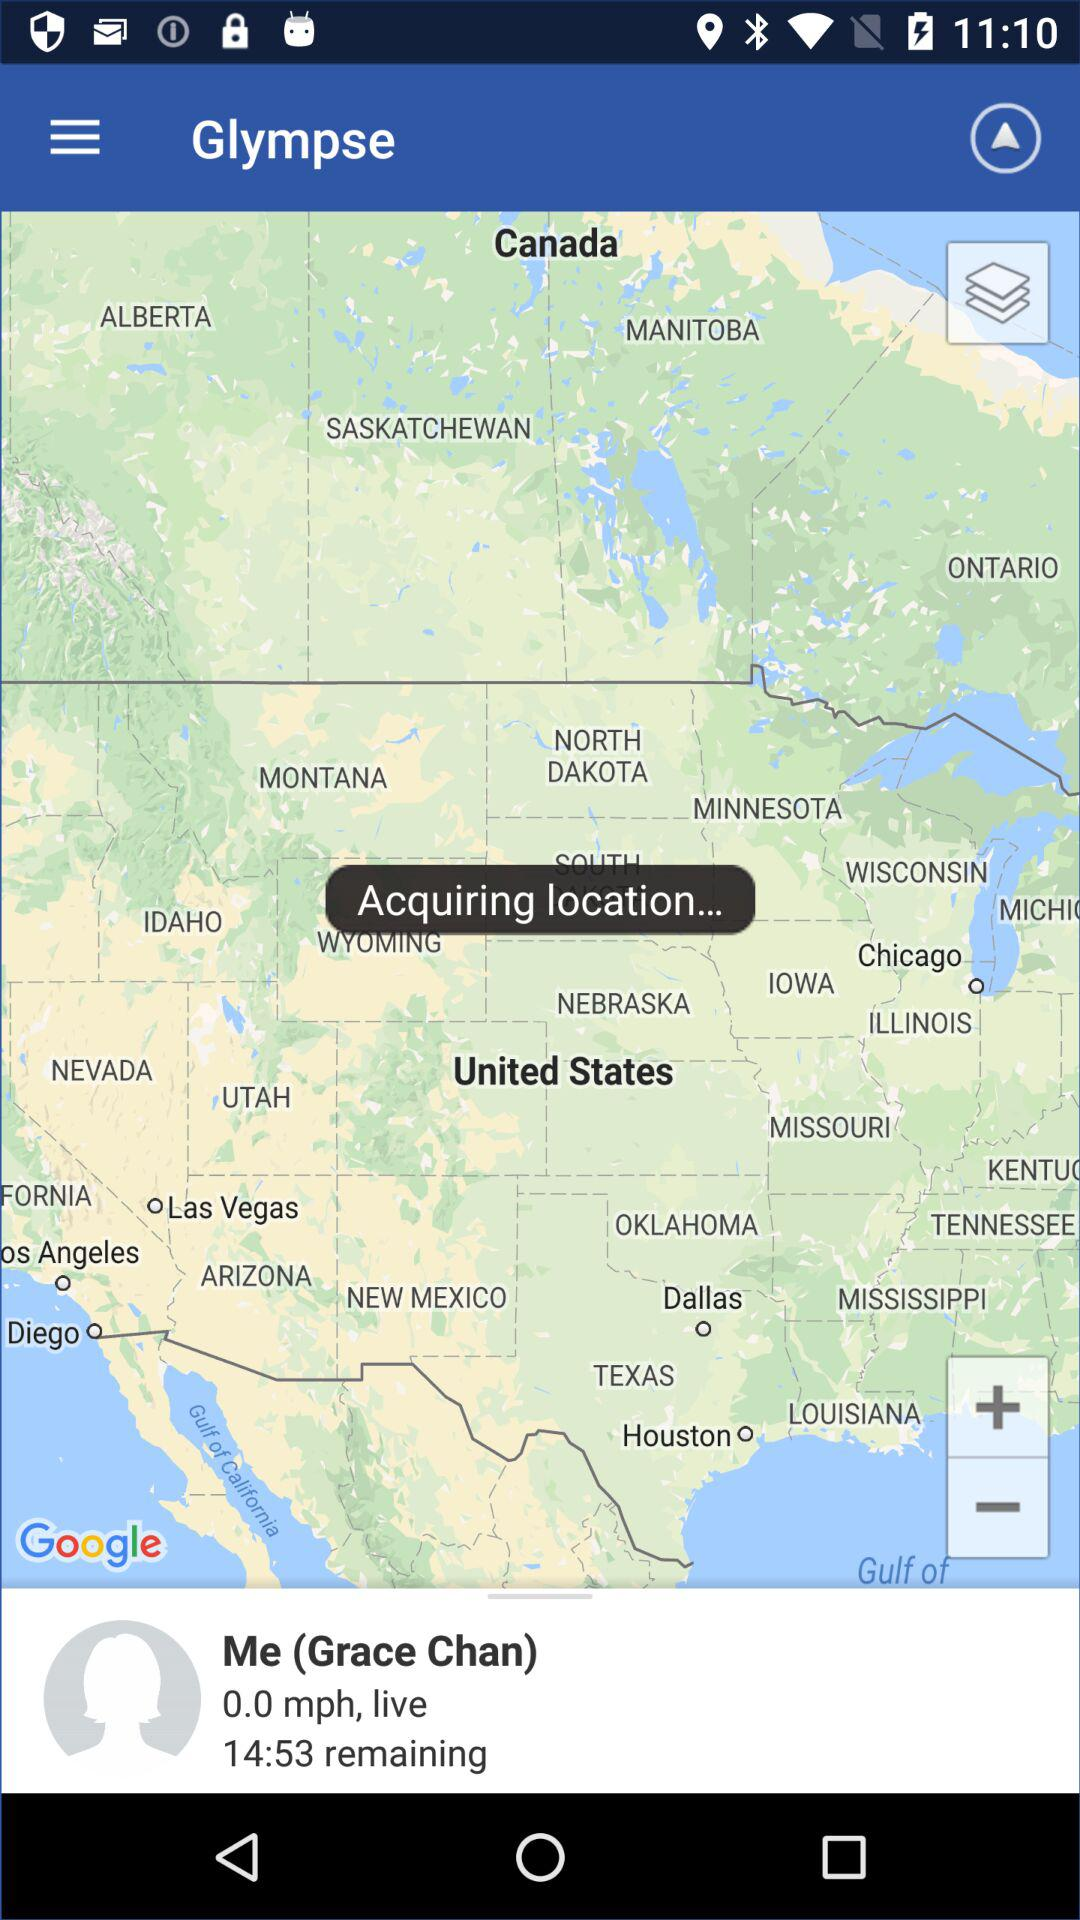How many social media accounts are not connected?
Answer the question using a single word or phrase. 3 